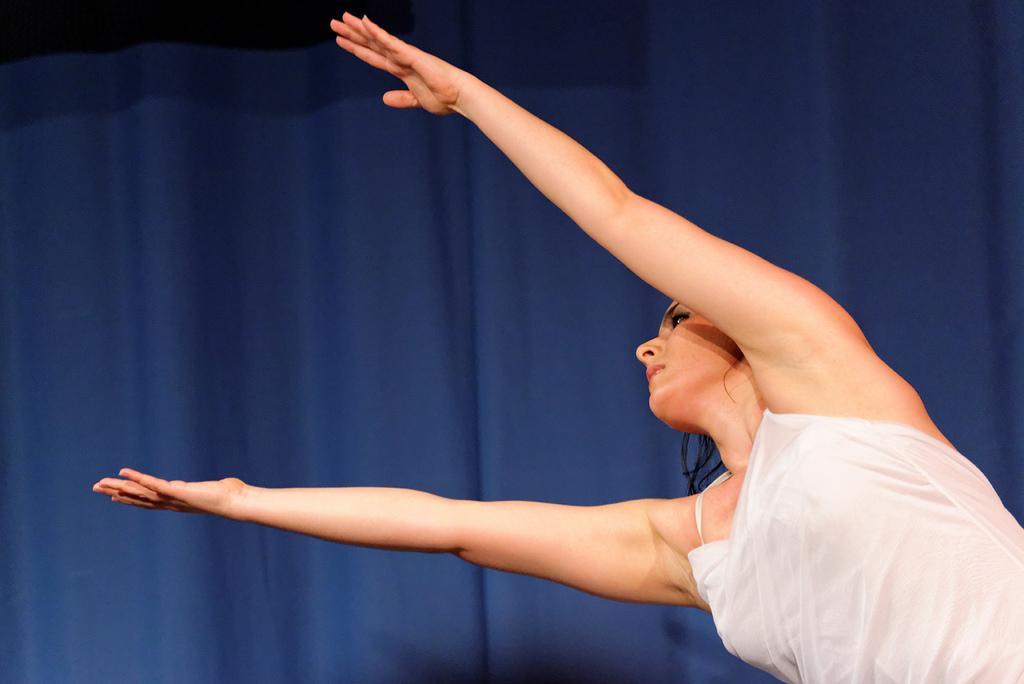In one or two sentences, can you explain what this image depicts? In the center of the image, we can see a lady and in the background, there is a curtain. 